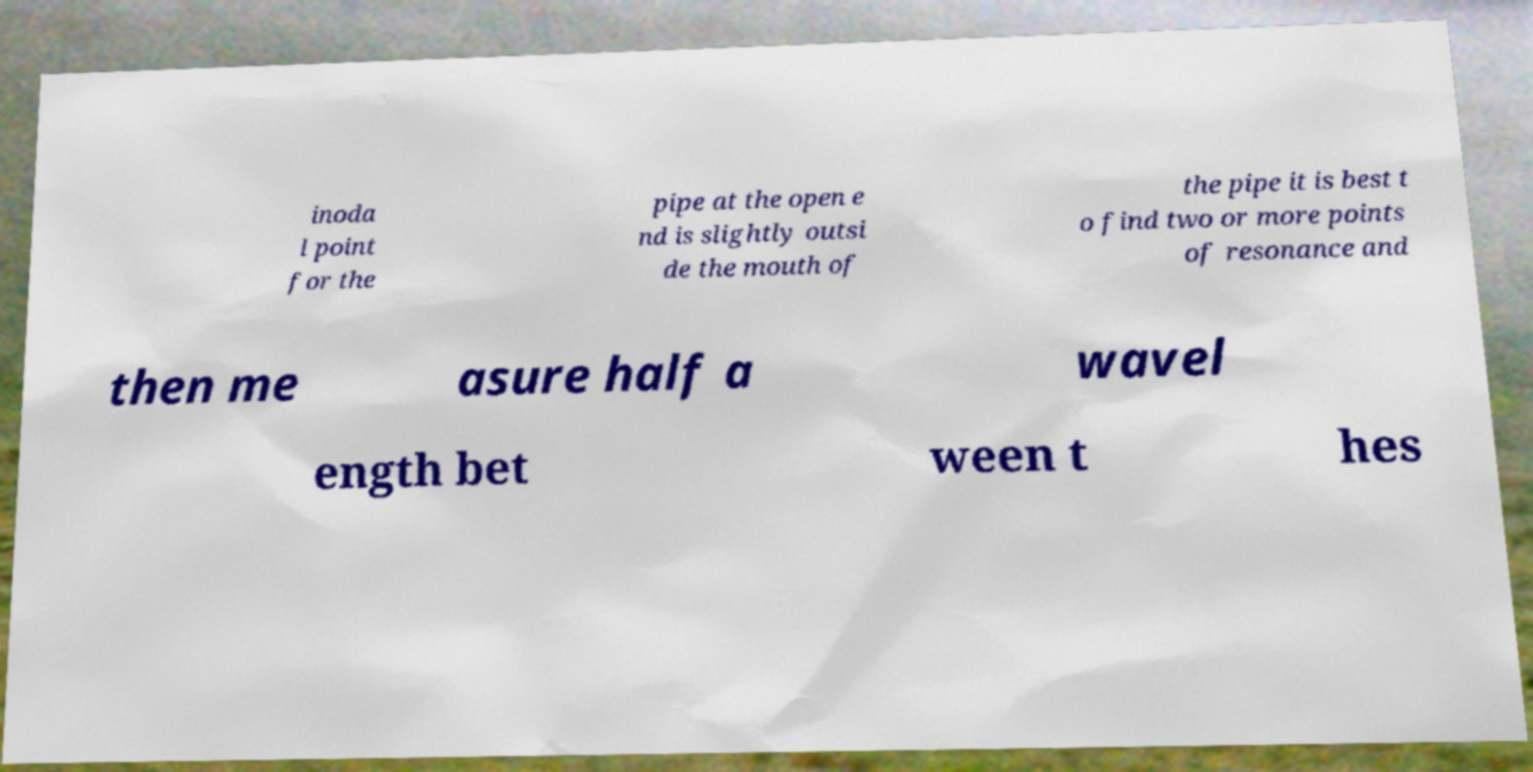Could you extract and type out the text from this image? inoda l point for the pipe at the open e nd is slightly outsi de the mouth of the pipe it is best t o find two or more points of resonance and then me asure half a wavel ength bet ween t hes 